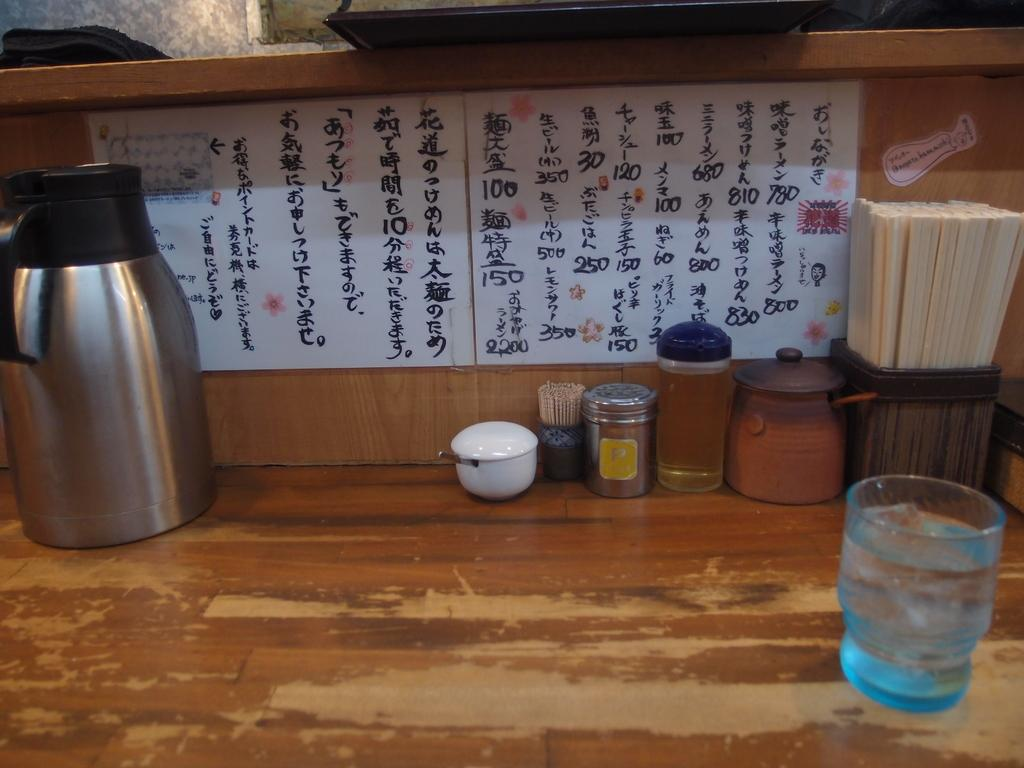What piece of furniture is in the image? There is a table in the image. What items are on the table? A flask, a cup, a steel box, a jar, a pot, and a water glass are on the table. What is in the background of the image? There is a whiteboard in the background. What can be seen on the whiteboard? Text is written on the whiteboard. What type of chin can be seen on the instrument in the image? There is no instrument or chin present in the image. How many baseballs are visible on the table in the image? There are no baseballs present in the image. 